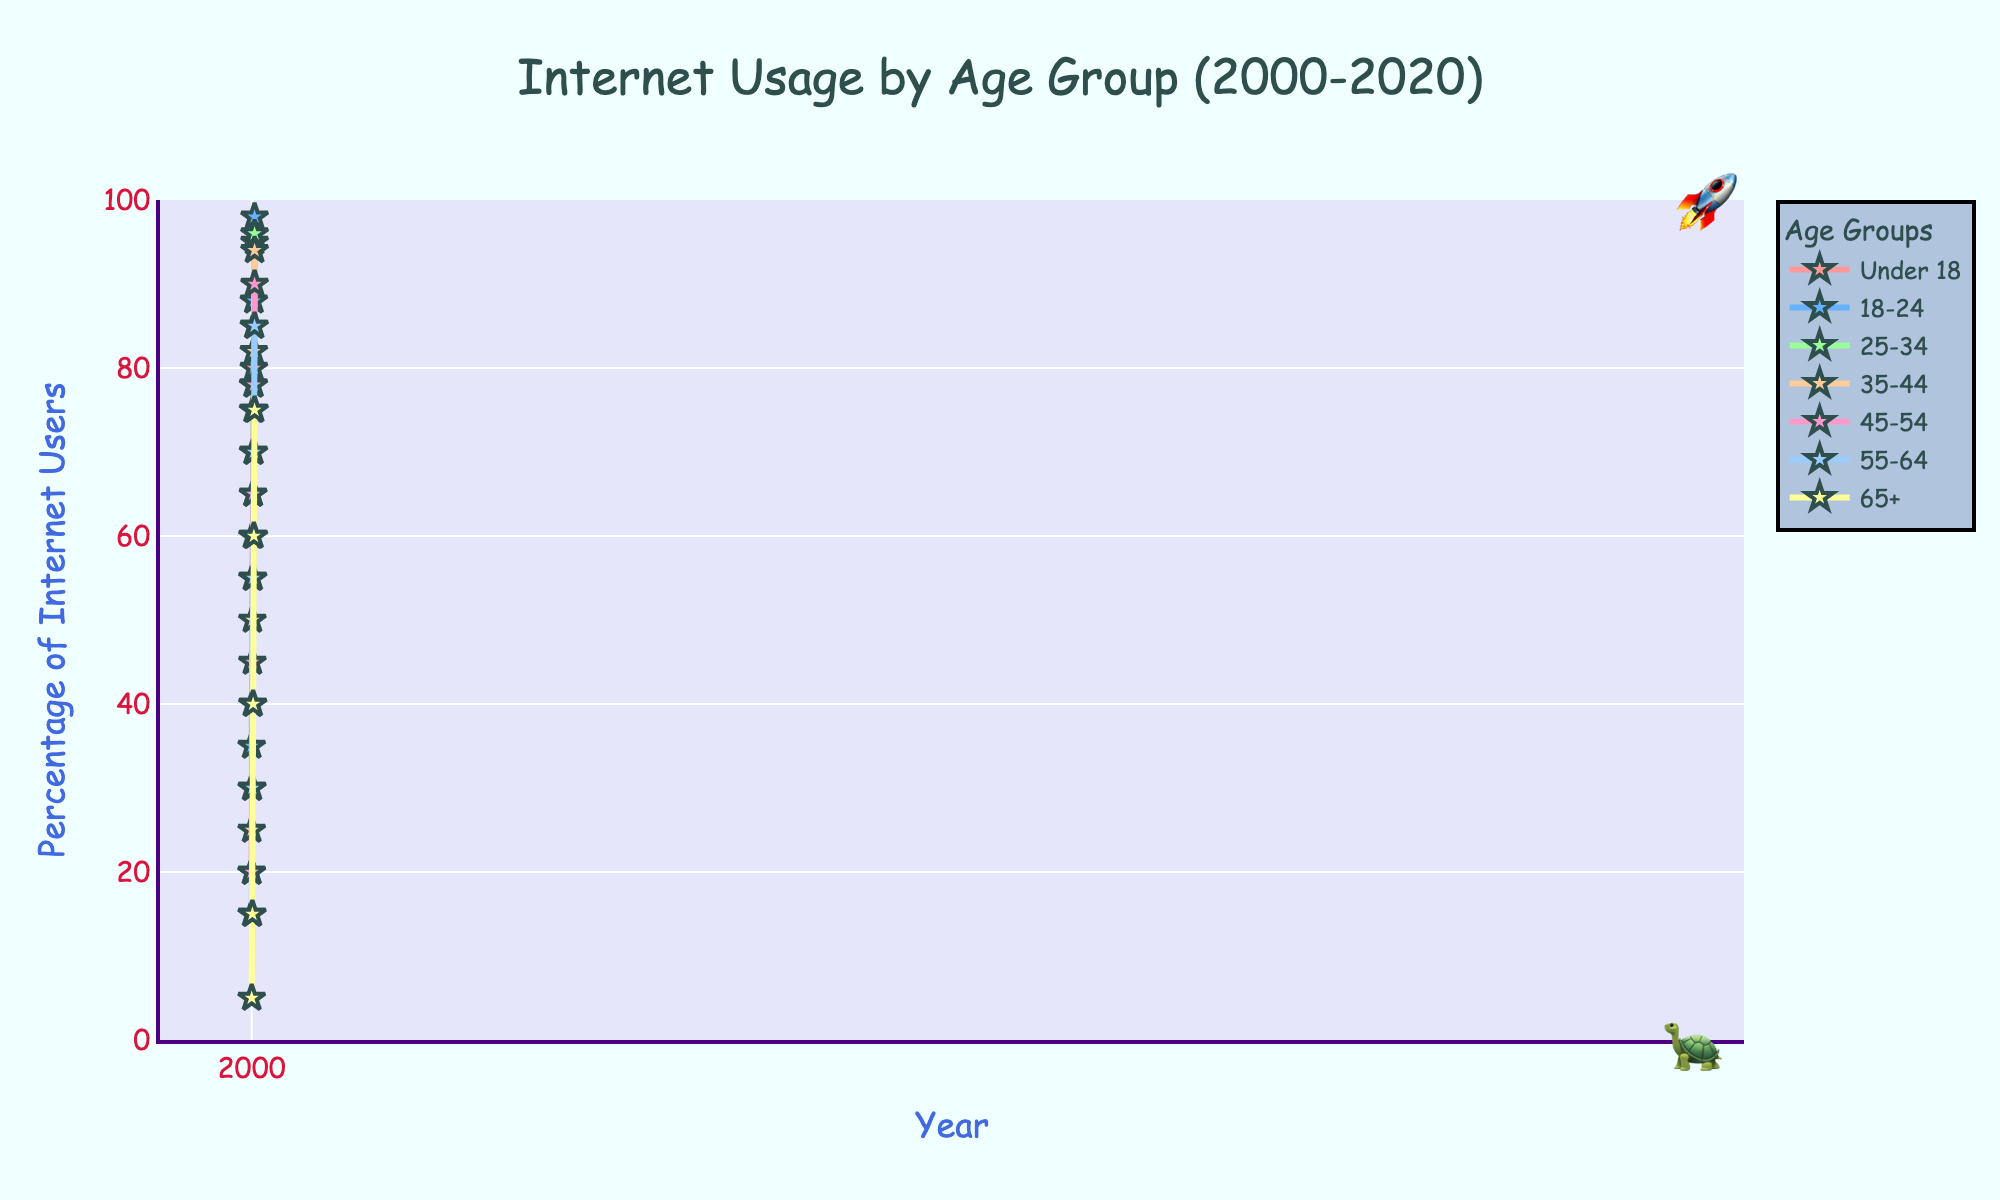What was the percentage of Internet users under 18 in 2020, and how much did that change compared to 2000? The figure shows that in 2020, the percentage of Internet users under 18 was 95%. In 2000, it was 20%. The change is 95% - 20% = 75%.
Answer: 75% Which age group saw the biggest increase in Internet usage from 2000 to 2020? Comparing the percentages of all age groups from 2000 to 2020, the 65+ age group increased from 5% to 75%, a change of 70%. This is the largest increase.
Answer: 65+ Did any age group reach 100% Internet usage by 2020? None of the age groups hit 100% in 2020 as the highest value is 98% for the 18-24 age group.
Answer: No Between 2010 and 2015, which age group had the smallest increase in Internet usage? Calculating the percentage increase between 2010 and 2015, the 55-64 age group increased from 55% to 70%, which is 15%, the smallest increase among all groups in that period.
Answer: 55-64 In which year did the 35-44 age group Internet usage surpass 70%? Referring to the line for the 35-44 age group, it surpassed 70% in the year 2010.
Answer: 2010 What is the average Internet usage percentage for the 25-34 age group over the two decades presented? To find the average: (30 + 55 + 75 + 85 + 96) / 5 = 341 / 5 = 68.2%.
Answer: 68.2% Is the Internet usage of the 45-54 age group in 2020 greater than the 55-64 age group in 2015? Yes, in 2020 the 45-54 age group had 90% while the 55-64 age group in 2015 had 70%. 90% > 70%.
Answer: Yes What is the difference in Internet usage between age groups 18-24 and under 18 in 2020? In 2020, age group 18-24 has 98% and under 18 has 95%. The difference is 98% - 95% = 3%.
Answer: 3% Which age group had Internet usage closest to 60% in 2005? The age group with Internet usage closest to 60% in 2005 was the 18-24 age group, which had 60%.
Answer: 18-24 What was the trend of Internet usage for the 65+ age group between 2000 and 2020? The Internet usage of the 65+ age group steadily increased from 5% in 2000 to 75% in 2020.
Answer: Steadily increased 